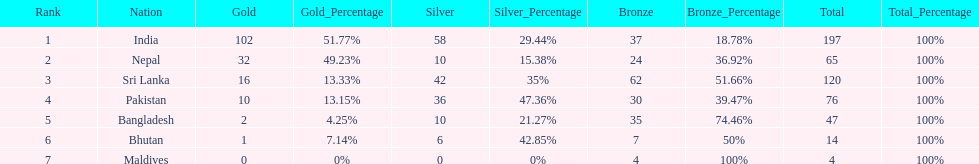What are the total number of bronze medals sri lanka have earned? 62. Would you be able to parse every entry in this table? {'header': ['Rank', 'Nation', 'Gold', 'Gold_Percentage', 'Silver', 'Silver_Percentage', 'Bronze', 'Bronze_Percentage', 'Total', 'Total_Percentage'], 'rows': [['1', 'India', '102', '51.77%', '58', '29.44%', '37', '18.78%', '197', '100%'], ['2', 'Nepal', '32', '49.23%', '10', '15.38%', '24', '36.92%', '65', '100%'], ['3', 'Sri Lanka', '16', '13.33%', '42', '35%', '62', '51.66%', '120', '100%'], ['4', 'Pakistan', '10', '13.15%', '36', '47.36%', '30', '39.47%', '76', '100%'], ['5', 'Bangladesh', '2', '4.25%', '10', '21.27%', '35', '74.46%', '47', '100%'], ['6', 'Bhutan', '1', '7.14%', '6', '42.85%', '7', '50%', '14', '100%'], ['7', 'Maldives', '0', '0%', '0', '0%', '4', '100%', '4', '100%']]} 